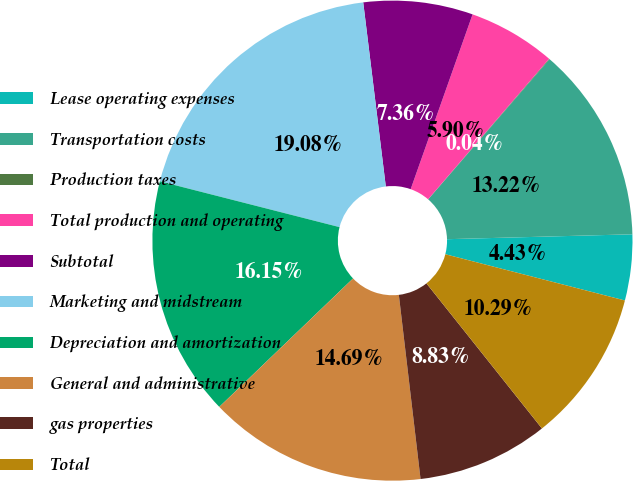Convert chart to OTSL. <chart><loc_0><loc_0><loc_500><loc_500><pie_chart><fcel>Lease operating expenses<fcel>Transportation costs<fcel>Production taxes<fcel>Total production and operating<fcel>Subtotal<fcel>Marketing and midstream<fcel>Depreciation and amortization<fcel>General and administrative<fcel>gas properties<fcel>Total<nl><fcel>4.43%<fcel>13.22%<fcel>0.04%<fcel>5.9%<fcel>7.36%<fcel>19.08%<fcel>16.15%<fcel>14.69%<fcel>8.83%<fcel>10.29%<nl></chart> 